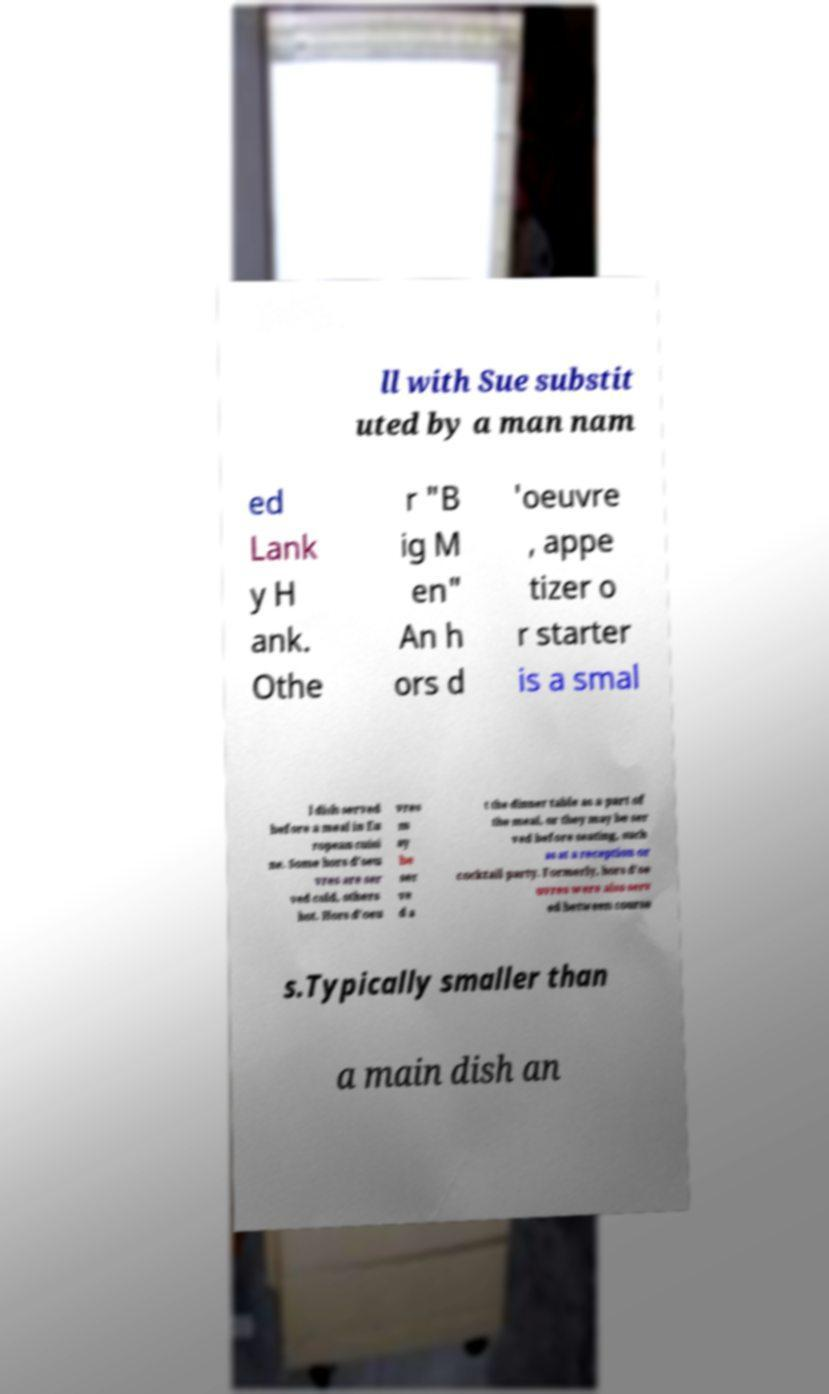Could you extract and type out the text from this image? ll with Sue substit uted by a man nam ed Lank y H ank. Othe r "B ig M en" An h ors d 'oeuvre , appe tizer o r starter is a smal l dish served before a meal in Eu ropean cuisi ne. Some hors d'oeu vres are ser ved cold, others hot. Hors d'oeu vres m ay be ser ve d a t the dinner table as a part of the meal, or they may be ser ved before seating, such as at a reception or cocktail party. Formerly, hors d'oe uvres were also serv ed between course s.Typically smaller than a main dish an 